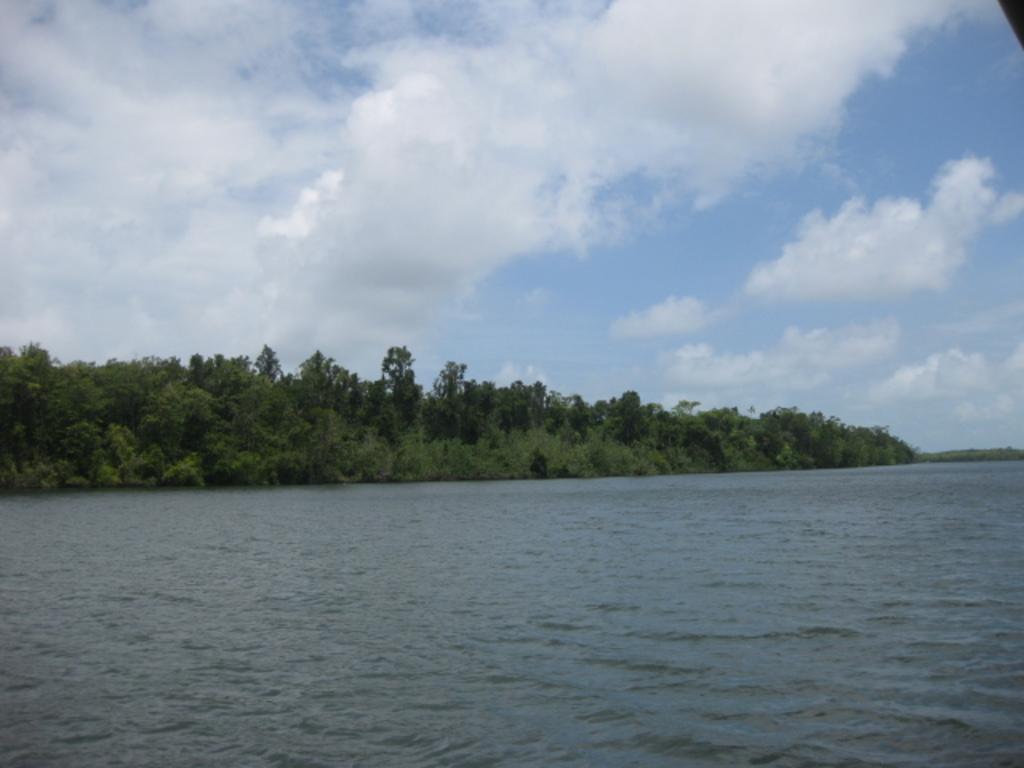Describe this image in one or two sentences. At the bottom of the image there is a river. In the center there are trees. At the top there is sky. 